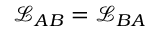<formula> <loc_0><loc_0><loc_500><loc_500>\mathcal { L } _ { A B } = \mathcal { L } _ { B A }</formula> 